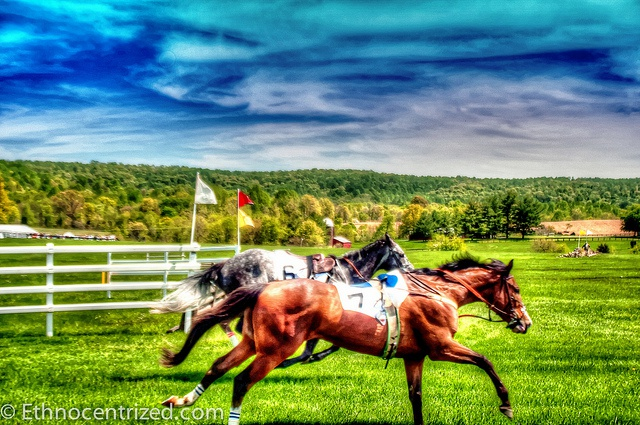Describe the objects in this image and their specific colors. I can see horse in blue, black, maroon, ivory, and brown tones and horse in blue, white, black, gray, and darkgray tones in this image. 